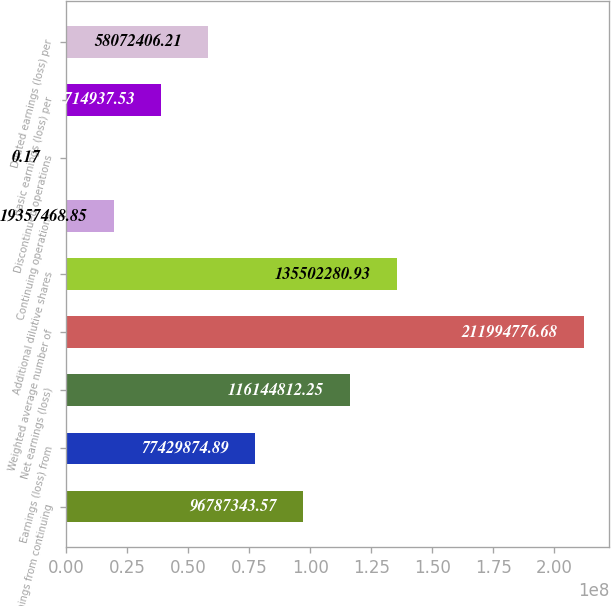<chart> <loc_0><loc_0><loc_500><loc_500><bar_chart><fcel>Earnings from continuing<fcel>Earnings (loss) from<fcel>Net earnings (loss)<fcel>Weighted average number of<fcel>Additional dilutive shares<fcel>Continuing operations<fcel>Discontinued operations<fcel>Basic earnings (loss) per<fcel>Diluted earnings (loss) per<nl><fcel>9.67873e+07<fcel>7.74299e+07<fcel>1.16145e+08<fcel>2.11995e+08<fcel>1.35502e+08<fcel>1.93575e+07<fcel>0.17<fcel>3.87149e+07<fcel>5.80724e+07<nl></chart> 